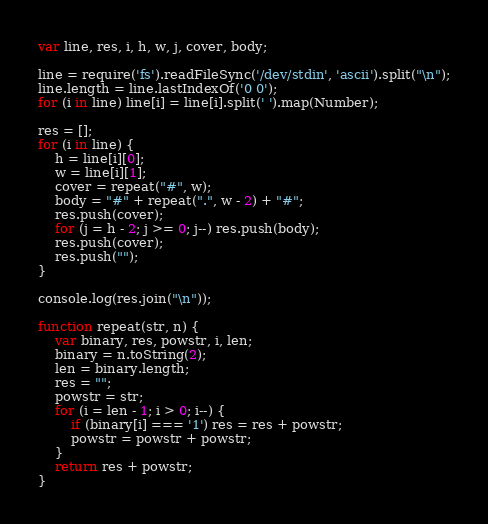<code> <loc_0><loc_0><loc_500><loc_500><_JavaScript_>var line, res, i, h, w, j, cover, body;

line = require('fs').readFileSync('/dev/stdin', 'ascii').split("\n");
line.length = line.lastIndexOf('0 0');
for (i in line) line[i] = line[i].split(' ').map(Number);

res = [];
for (i in line) {
	h = line[i][0];
	w = line[i][1];
	cover = repeat("#", w);
	body = "#" + repeat(".", w - 2) + "#";
	res.push(cover);
	for (j = h - 2; j >= 0; j--) res.push(body);
	res.push(cover);
	res.push("");
}

console.log(res.join("\n"));

function repeat(str, n) {
	var binary, res, powstr, i, len;
	binary = n.toString(2);
	len = binary.length;
	res = "";
	powstr = str;
	for (i = len - 1; i > 0; i--) {
		if (binary[i] === '1') res = res + powstr;
		powstr = powstr + powstr;
	}
	return res + powstr;
}</code> 